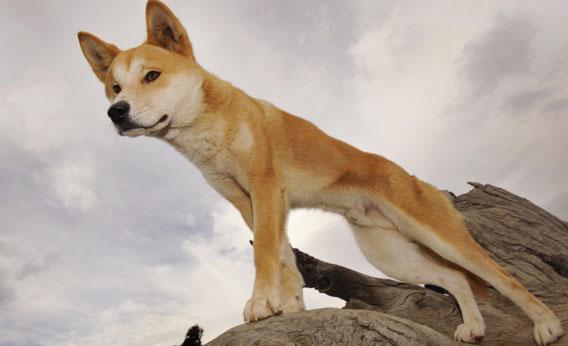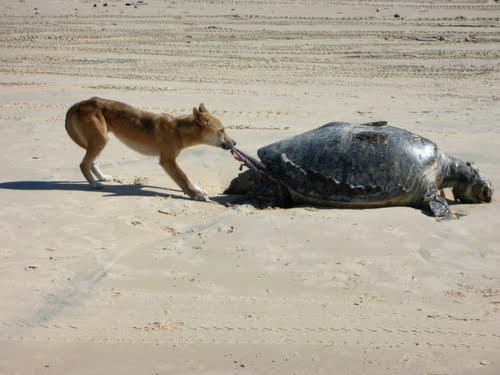The first image is the image on the left, the second image is the image on the right. Evaluate the accuracy of this statement regarding the images: "The dingo's body in the left image is facing towards the left.". Is it true? Answer yes or no. Yes. The first image is the image on the left, the second image is the image on the right. Given the left and right images, does the statement "A dog is at the left of an image, standing behind a dead animal washed up on a beach." hold true? Answer yes or no. Yes. 